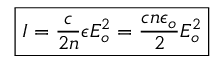<formula> <loc_0><loc_0><loc_500><loc_500>\boxed { I = \frac { c } { 2 n } \epsilon E _ { o } ^ { 2 } = \frac { c n \epsilon _ { o } } { 2 } E _ { o } ^ { 2 } }</formula> 